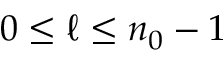<formula> <loc_0><loc_0><loc_500><loc_500>0 \leq \ell \leq n _ { 0 } - 1</formula> 